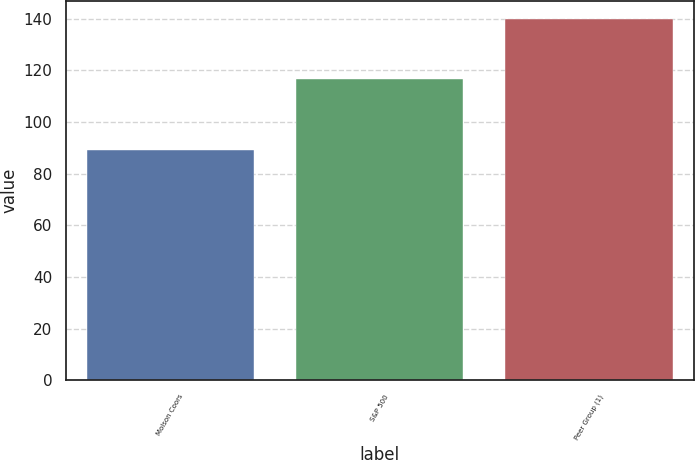<chart> <loc_0><loc_0><loc_500><loc_500><bar_chart><fcel>Molson Coors<fcel>S&P 500<fcel>Peer Group (1)<nl><fcel>89.01<fcel>116.58<fcel>139.75<nl></chart> 